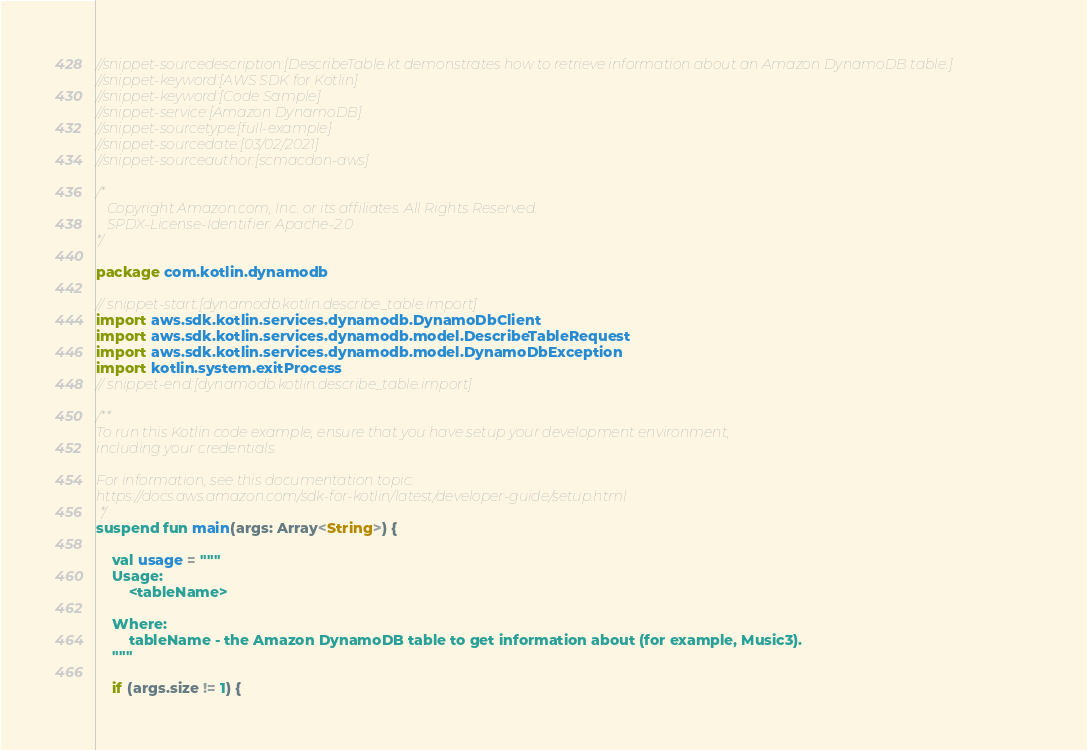Convert code to text. <code><loc_0><loc_0><loc_500><loc_500><_Kotlin_>//snippet-sourcedescription:[DescribeTable.kt demonstrates how to retrieve information about an Amazon DynamoDB table.]
//snippet-keyword:[AWS SDK for Kotlin]
//snippet-keyword:[Code Sample]
//snippet-service:[Amazon DynamoDB]
//snippet-sourcetype:[full-example]
//snippet-sourcedate:[03/02/2021]
//snippet-sourceauthor:[scmacdon-aws]

/*
   Copyright Amazon.com, Inc. or its affiliates. All Rights Reserved.
   SPDX-License-Identifier: Apache-2.0
*/

package com.kotlin.dynamodb

// snippet-start:[dynamodb.kotlin.describe_table.import]
import aws.sdk.kotlin.services.dynamodb.DynamoDbClient
import aws.sdk.kotlin.services.dynamodb.model.DescribeTableRequest
import aws.sdk.kotlin.services.dynamodb.model.DynamoDbException
import kotlin.system.exitProcess
// snippet-end:[dynamodb.kotlin.describe_table.import]

/**
To run this Kotlin code example, ensure that you have setup your development environment,
including your credentials.

For information, see this documentation topic:
https://docs.aws.amazon.com/sdk-for-kotlin/latest/developer-guide/setup.html
 */
suspend fun main(args: Array<String>) {

    val usage = """
    Usage:
        <tableName>

    Where:
        tableName - the Amazon DynamoDB table to get information about (for example, Music3).
    """

    if (args.size != 1) {</code> 